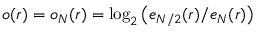<formula> <loc_0><loc_0><loc_500><loc_500>o ( r ) = o _ { N } ( r ) = \log _ { 2 } \left ( e _ { N / 2 } ( r ) / e _ { N } ( r ) \right )</formula> 